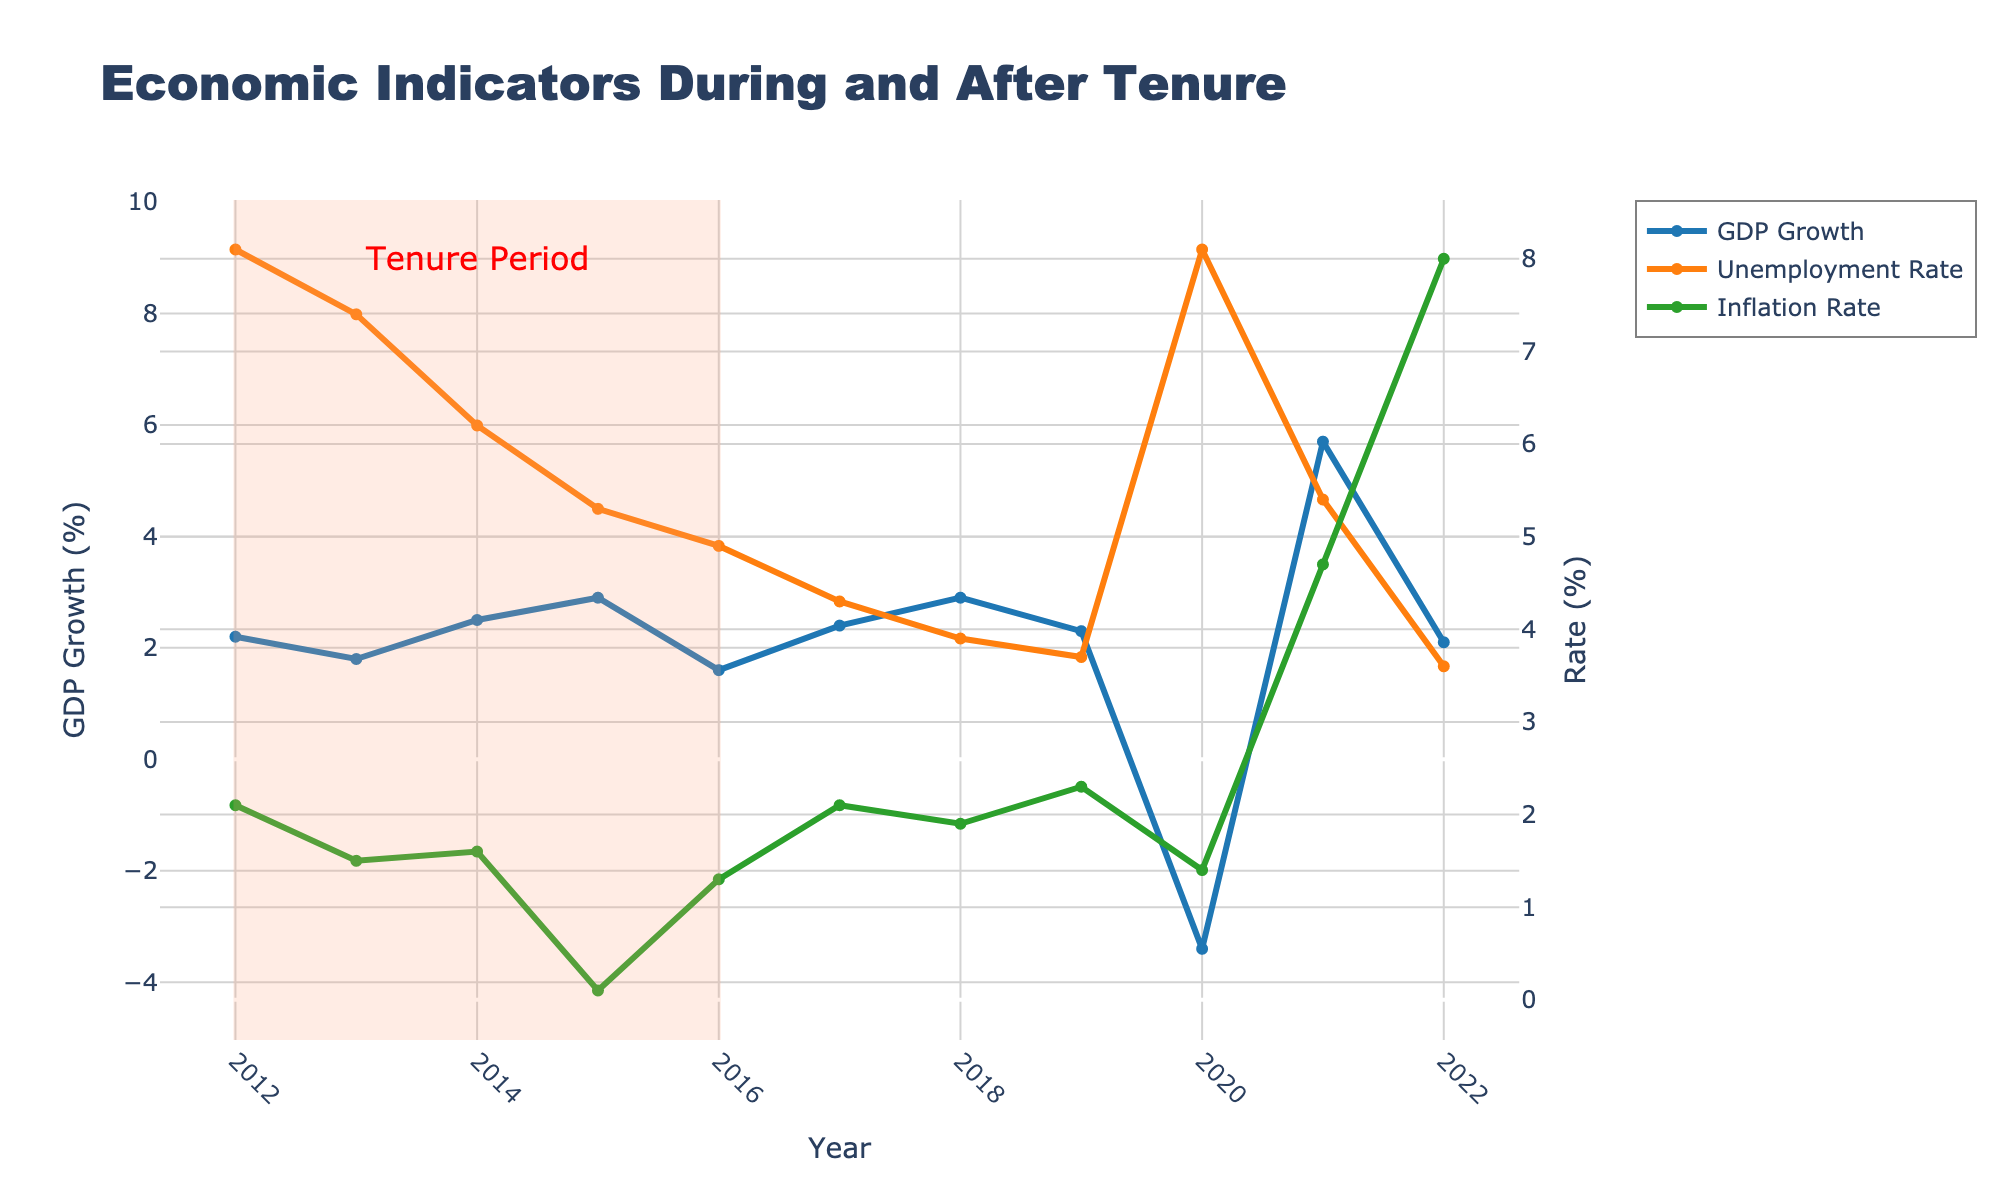What is the GDP growth rate in 2016? Look at the GDP Growth trend line and find the data point for the year 2016. The value is marked with a blue line with a marker.
Answer: 1.6% Compare the unemployment rate between 2012 and 2016. Which year had a lower rate? Find the unemployment rate trend line and compare the data points for the years 2012 and 2016. 2016 has a lower rate.
Answer: 2016 What is the average inflation rate from 2012 to 2016? Add the inflation rates from 2012 to 2016 and divide by the number of years (5). (2.1 + 1.5 + 1.6 + 0.1 + 1.3) / 5 = 6.6 / 5 = 1.32
Answer: 1.32% Which year experienced the highest GDP growth rate, and what was the rate? Find the peak value on the GDP Growth trend line. The peak occurs in 2021 at a rate of 5.7%.
Answer: 2021, 5.7% How did the inflation rate change from 2020 to 2022? Look at the inflation rate trend line and compare the points for 2020 and 2022. The rate increased from 1.4% to 8.0%.
Answer: Increased What’s the difference in the unemployment rate between 2015 and 2021? Subtract the unemployment rate in 2015 from that in 2021. 5.4% - 5.3% = 0.1%
Answer: 0.1% Compare the color of the GDP growth trend line to inflation rate trend line. Describe their colors. Identify the colors of the lines representing GDP growth and inflation rate. GDP growth is blue, inflation rate is green.
Answer: Blue and green How many years after 2012 did the unemployment rate first fall below 5%? Identify the point where the unemployment rate trend line first drops below 5%. It falls below 5% in 2016, which is 4 years after 2012.
Answer: 4 years What was the GDP growth rate trend during the tenure period from 2012 to 2016? Observe the shape of the GDP Growth trend line within the highlighted tenure period. The GDP growth started at 2.2%, fluctuated, and eventually declined to 1.6%.
Answer: Fluctuated then Declined 